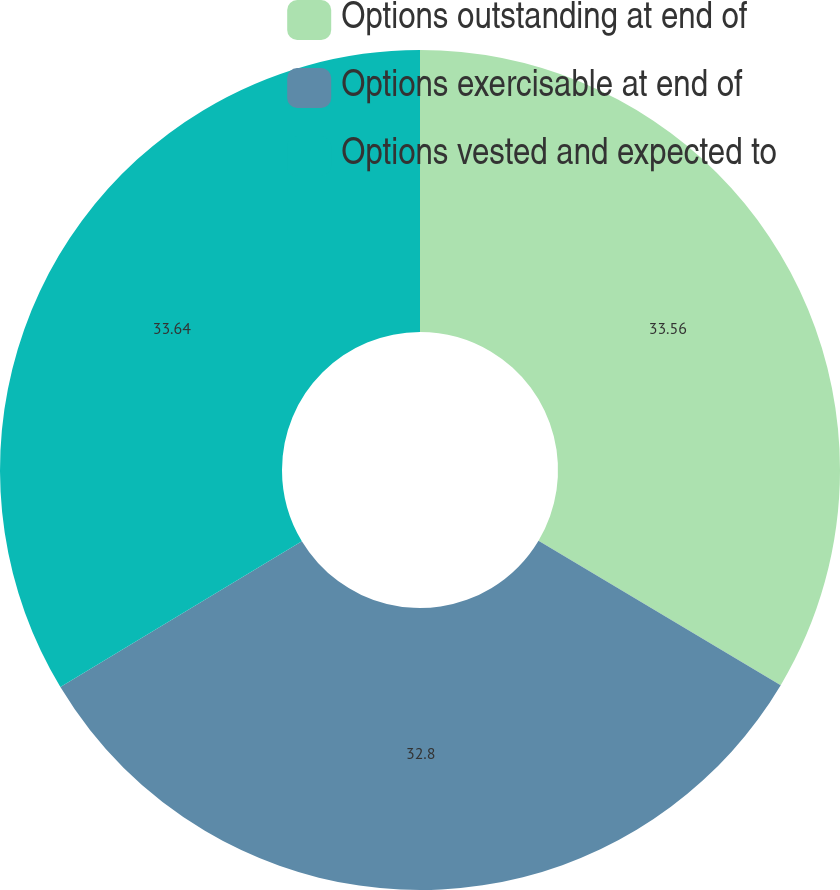Convert chart. <chart><loc_0><loc_0><loc_500><loc_500><pie_chart><fcel>Options outstanding at end of<fcel>Options exercisable at end of<fcel>Options vested and expected to<nl><fcel>33.56%<fcel>32.8%<fcel>33.64%<nl></chart> 